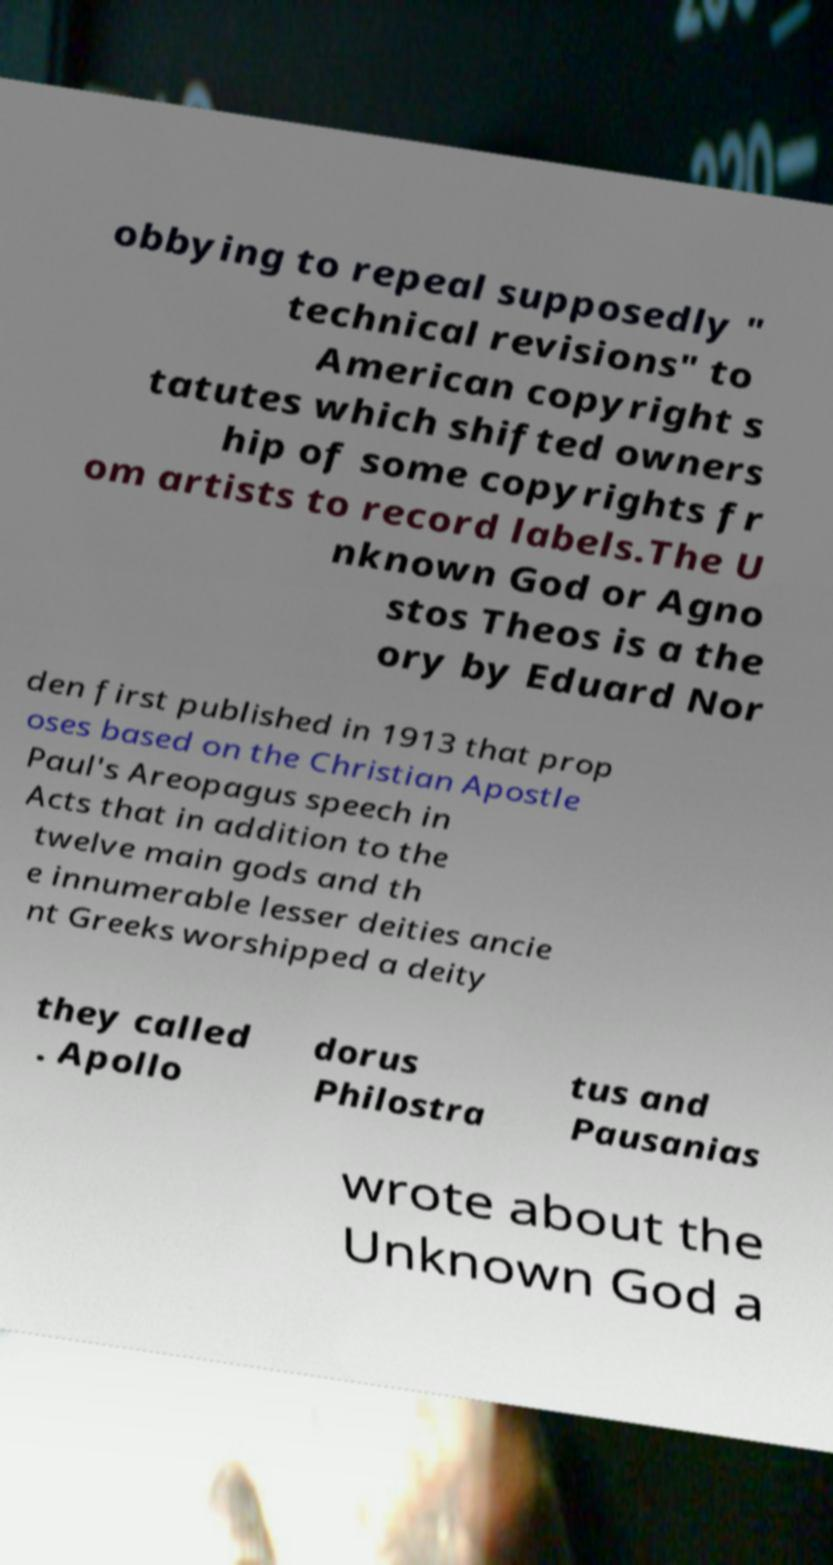For documentation purposes, I need the text within this image transcribed. Could you provide that? obbying to repeal supposedly " technical revisions" to American copyright s tatutes which shifted owners hip of some copyrights fr om artists to record labels.The U nknown God or Agno stos Theos is a the ory by Eduard Nor den first published in 1913 that prop oses based on the Christian Apostle Paul's Areopagus speech in Acts that in addition to the twelve main gods and th e innumerable lesser deities ancie nt Greeks worshipped a deity they called . Apollo dorus Philostra tus and Pausanias wrote about the Unknown God a 